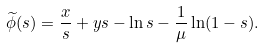<formula> <loc_0><loc_0><loc_500><loc_500>\widetilde { \phi } ( s ) = \frac { x } { s } + y s - \ln s - \frac { 1 } { \mu } \ln ( 1 - s ) .</formula> 